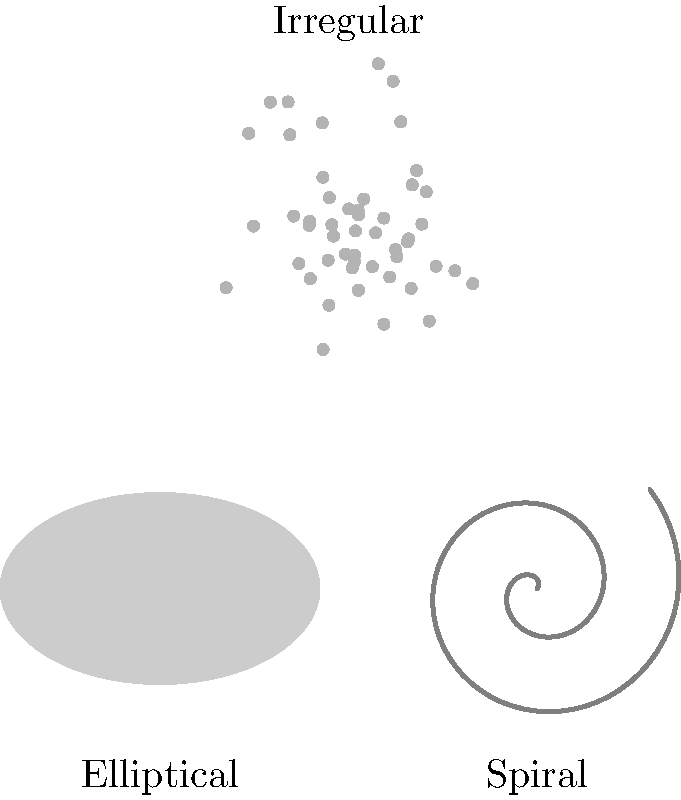As a fisherman who navigates by the stars, you've become fascinated with the shapes of galaxies. Which type of galaxy is known for its distinct spiral arms, similar to the swirling patterns you sometimes observe in river currents? To answer this question, let's examine the characteristics of the three main types of galaxies shown in the image:

1. Elliptical galaxies:
   - Smooth, featureless appearance
   - Elliptical or circular shape
   - No distinct structural features

2. Spiral galaxies:
   - Characterized by a central bulge
   - Distinct spiral arms extending from the center
   - Similar to swirling patterns observed in nature, such as river currents or whirlpools

3. Irregular galaxies:
   - No definite shape or structure
   - Appear chaotic and disorganized
   - Lack the symmetry of elliptical or spiral galaxies

Among these types, the spiral galaxy is the one that exhibits distinct spiral arms. This structure is reminiscent of the swirling patterns a fisherman might observe in river currents, making it the most relevant to the given persona.
Answer: Spiral galaxy 